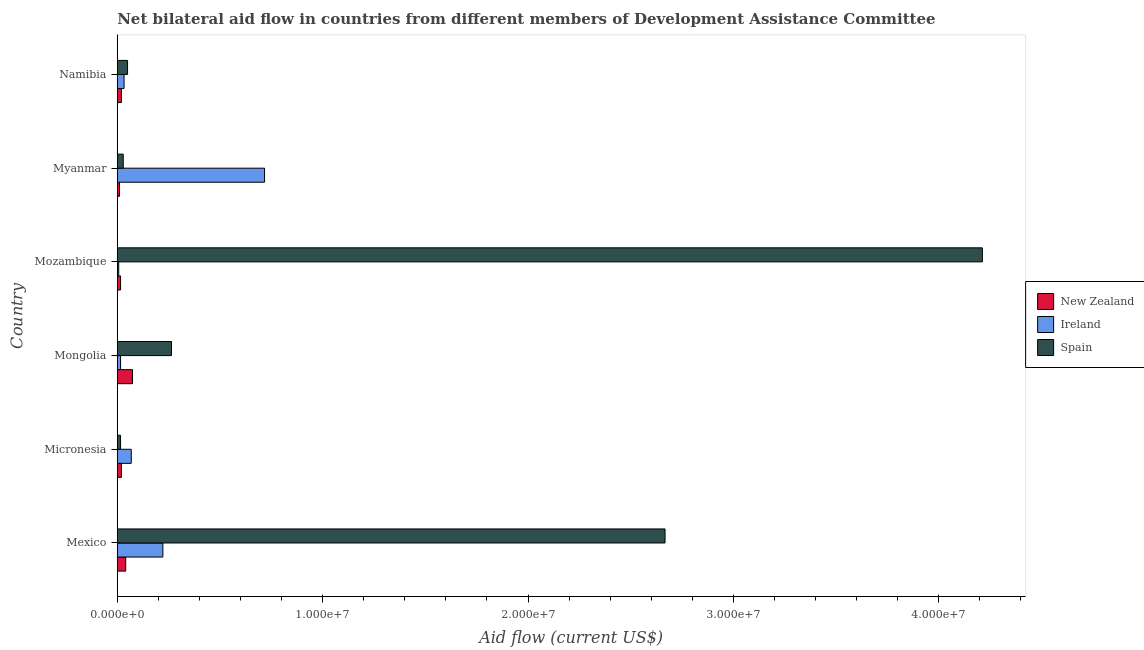Are the number of bars on each tick of the Y-axis equal?
Keep it short and to the point. Yes. How many bars are there on the 1st tick from the bottom?
Provide a succinct answer. 3. What is the label of the 1st group of bars from the top?
Ensure brevity in your answer.  Namibia. In how many cases, is the number of bars for a given country not equal to the number of legend labels?
Ensure brevity in your answer.  0. What is the amount of aid provided by new zealand in Namibia?
Ensure brevity in your answer.  2.00e+05. Across all countries, what is the maximum amount of aid provided by ireland?
Your response must be concise. 7.17e+06. Across all countries, what is the minimum amount of aid provided by new zealand?
Give a very brief answer. 1.10e+05. In which country was the amount of aid provided by ireland maximum?
Offer a very short reply. Myanmar. In which country was the amount of aid provided by new zealand minimum?
Offer a very short reply. Myanmar. What is the total amount of aid provided by new zealand in the graph?
Your answer should be very brief. 1.82e+06. What is the difference between the amount of aid provided by ireland in Mongolia and that in Namibia?
Your answer should be very brief. -1.70e+05. What is the difference between the amount of aid provided by spain in Mozambique and the amount of aid provided by ireland in Namibia?
Make the answer very short. 4.18e+07. What is the average amount of aid provided by new zealand per country?
Keep it short and to the point. 3.03e+05. What is the difference between the amount of aid provided by new zealand and amount of aid provided by ireland in Myanmar?
Your answer should be compact. -7.06e+06. In how many countries, is the amount of aid provided by spain greater than 34000000 US$?
Give a very brief answer. 1. What is the ratio of the amount of aid provided by ireland in Mongolia to that in Namibia?
Give a very brief answer. 0.48. Is the amount of aid provided by ireland in Mexico less than that in Myanmar?
Provide a succinct answer. Yes. Is the difference between the amount of aid provided by new zealand in Mongolia and Myanmar greater than the difference between the amount of aid provided by ireland in Mongolia and Myanmar?
Offer a terse response. Yes. What is the difference between the highest and the second highest amount of aid provided by new zealand?
Offer a very short reply. 3.30e+05. What is the difference between the highest and the lowest amount of aid provided by spain?
Ensure brevity in your answer.  4.20e+07. Is the sum of the amount of aid provided by new zealand in Micronesia and Mongolia greater than the maximum amount of aid provided by ireland across all countries?
Your response must be concise. No. What does the 3rd bar from the top in Micronesia represents?
Provide a short and direct response. New Zealand. What does the 1st bar from the bottom in Mexico represents?
Provide a succinct answer. New Zealand. Is it the case that in every country, the sum of the amount of aid provided by new zealand and amount of aid provided by ireland is greater than the amount of aid provided by spain?
Keep it short and to the point. No. How many countries are there in the graph?
Your answer should be compact. 6. What is the difference between two consecutive major ticks on the X-axis?
Provide a short and direct response. 1.00e+07. Are the values on the major ticks of X-axis written in scientific E-notation?
Keep it short and to the point. Yes. Where does the legend appear in the graph?
Make the answer very short. Center right. How many legend labels are there?
Your answer should be very brief. 3. What is the title of the graph?
Give a very brief answer. Net bilateral aid flow in countries from different members of Development Assistance Committee. What is the label or title of the X-axis?
Your answer should be very brief. Aid flow (current US$). What is the Aid flow (current US$) of Ireland in Mexico?
Provide a short and direct response. 2.22e+06. What is the Aid flow (current US$) in Spain in Mexico?
Offer a very short reply. 2.67e+07. What is the Aid flow (current US$) of New Zealand in Micronesia?
Ensure brevity in your answer.  2.00e+05. What is the Aid flow (current US$) in Ireland in Micronesia?
Keep it short and to the point. 6.80e+05. What is the Aid flow (current US$) in Spain in Micronesia?
Provide a succinct answer. 1.60e+05. What is the Aid flow (current US$) in New Zealand in Mongolia?
Your answer should be very brief. 7.40e+05. What is the Aid flow (current US$) of Spain in Mongolia?
Keep it short and to the point. 2.64e+06. What is the Aid flow (current US$) of Ireland in Mozambique?
Provide a short and direct response. 7.00e+04. What is the Aid flow (current US$) in Spain in Mozambique?
Your answer should be compact. 4.21e+07. What is the Aid flow (current US$) of New Zealand in Myanmar?
Give a very brief answer. 1.10e+05. What is the Aid flow (current US$) of Ireland in Myanmar?
Give a very brief answer. 7.17e+06. What is the Aid flow (current US$) of New Zealand in Namibia?
Give a very brief answer. 2.00e+05. What is the Aid flow (current US$) in Ireland in Namibia?
Offer a terse response. 3.30e+05. What is the Aid flow (current US$) in Spain in Namibia?
Provide a short and direct response. 5.00e+05. Across all countries, what is the maximum Aid flow (current US$) in New Zealand?
Make the answer very short. 7.40e+05. Across all countries, what is the maximum Aid flow (current US$) of Ireland?
Give a very brief answer. 7.17e+06. Across all countries, what is the maximum Aid flow (current US$) in Spain?
Your answer should be very brief. 4.21e+07. Across all countries, what is the minimum Aid flow (current US$) of Ireland?
Your response must be concise. 7.00e+04. Across all countries, what is the minimum Aid flow (current US$) of Spain?
Provide a short and direct response. 1.60e+05. What is the total Aid flow (current US$) of New Zealand in the graph?
Your response must be concise. 1.82e+06. What is the total Aid flow (current US$) of Ireland in the graph?
Make the answer very short. 1.06e+07. What is the total Aid flow (current US$) of Spain in the graph?
Provide a short and direct response. 7.24e+07. What is the difference between the Aid flow (current US$) of Ireland in Mexico and that in Micronesia?
Offer a very short reply. 1.54e+06. What is the difference between the Aid flow (current US$) in Spain in Mexico and that in Micronesia?
Make the answer very short. 2.65e+07. What is the difference between the Aid flow (current US$) in New Zealand in Mexico and that in Mongolia?
Give a very brief answer. -3.30e+05. What is the difference between the Aid flow (current US$) in Ireland in Mexico and that in Mongolia?
Offer a terse response. 2.06e+06. What is the difference between the Aid flow (current US$) in Spain in Mexico and that in Mongolia?
Give a very brief answer. 2.40e+07. What is the difference between the Aid flow (current US$) of Ireland in Mexico and that in Mozambique?
Offer a very short reply. 2.15e+06. What is the difference between the Aid flow (current US$) in Spain in Mexico and that in Mozambique?
Offer a terse response. -1.54e+07. What is the difference between the Aid flow (current US$) of New Zealand in Mexico and that in Myanmar?
Offer a very short reply. 3.00e+05. What is the difference between the Aid flow (current US$) of Ireland in Mexico and that in Myanmar?
Provide a succinct answer. -4.95e+06. What is the difference between the Aid flow (current US$) in Spain in Mexico and that in Myanmar?
Give a very brief answer. 2.64e+07. What is the difference between the Aid flow (current US$) of New Zealand in Mexico and that in Namibia?
Provide a succinct answer. 2.10e+05. What is the difference between the Aid flow (current US$) in Ireland in Mexico and that in Namibia?
Ensure brevity in your answer.  1.89e+06. What is the difference between the Aid flow (current US$) in Spain in Mexico and that in Namibia?
Offer a very short reply. 2.62e+07. What is the difference between the Aid flow (current US$) in New Zealand in Micronesia and that in Mongolia?
Offer a terse response. -5.40e+05. What is the difference between the Aid flow (current US$) of Ireland in Micronesia and that in Mongolia?
Your response must be concise. 5.20e+05. What is the difference between the Aid flow (current US$) of Spain in Micronesia and that in Mongolia?
Make the answer very short. -2.48e+06. What is the difference between the Aid flow (current US$) of Ireland in Micronesia and that in Mozambique?
Your answer should be very brief. 6.10e+05. What is the difference between the Aid flow (current US$) in Spain in Micronesia and that in Mozambique?
Provide a short and direct response. -4.20e+07. What is the difference between the Aid flow (current US$) of Ireland in Micronesia and that in Myanmar?
Your answer should be very brief. -6.49e+06. What is the difference between the Aid flow (current US$) in Spain in Micronesia and that in Myanmar?
Keep it short and to the point. -1.30e+05. What is the difference between the Aid flow (current US$) of New Zealand in Micronesia and that in Namibia?
Give a very brief answer. 0. What is the difference between the Aid flow (current US$) in New Zealand in Mongolia and that in Mozambique?
Keep it short and to the point. 5.80e+05. What is the difference between the Aid flow (current US$) in Ireland in Mongolia and that in Mozambique?
Offer a very short reply. 9.00e+04. What is the difference between the Aid flow (current US$) in Spain in Mongolia and that in Mozambique?
Offer a terse response. -3.95e+07. What is the difference between the Aid flow (current US$) in New Zealand in Mongolia and that in Myanmar?
Provide a succinct answer. 6.30e+05. What is the difference between the Aid flow (current US$) of Ireland in Mongolia and that in Myanmar?
Offer a very short reply. -7.01e+06. What is the difference between the Aid flow (current US$) in Spain in Mongolia and that in Myanmar?
Keep it short and to the point. 2.35e+06. What is the difference between the Aid flow (current US$) in New Zealand in Mongolia and that in Namibia?
Provide a short and direct response. 5.40e+05. What is the difference between the Aid flow (current US$) of Ireland in Mongolia and that in Namibia?
Provide a succinct answer. -1.70e+05. What is the difference between the Aid flow (current US$) of Spain in Mongolia and that in Namibia?
Make the answer very short. 2.14e+06. What is the difference between the Aid flow (current US$) in New Zealand in Mozambique and that in Myanmar?
Keep it short and to the point. 5.00e+04. What is the difference between the Aid flow (current US$) in Ireland in Mozambique and that in Myanmar?
Your response must be concise. -7.10e+06. What is the difference between the Aid flow (current US$) of Spain in Mozambique and that in Myanmar?
Keep it short and to the point. 4.18e+07. What is the difference between the Aid flow (current US$) of New Zealand in Mozambique and that in Namibia?
Keep it short and to the point. -4.00e+04. What is the difference between the Aid flow (current US$) of Ireland in Mozambique and that in Namibia?
Provide a short and direct response. -2.60e+05. What is the difference between the Aid flow (current US$) of Spain in Mozambique and that in Namibia?
Keep it short and to the point. 4.16e+07. What is the difference between the Aid flow (current US$) of Ireland in Myanmar and that in Namibia?
Offer a very short reply. 6.84e+06. What is the difference between the Aid flow (current US$) of New Zealand in Mexico and the Aid flow (current US$) of Spain in Micronesia?
Make the answer very short. 2.50e+05. What is the difference between the Aid flow (current US$) in Ireland in Mexico and the Aid flow (current US$) in Spain in Micronesia?
Offer a very short reply. 2.06e+06. What is the difference between the Aid flow (current US$) of New Zealand in Mexico and the Aid flow (current US$) of Spain in Mongolia?
Your answer should be very brief. -2.23e+06. What is the difference between the Aid flow (current US$) of Ireland in Mexico and the Aid flow (current US$) of Spain in Mongolia?
Make the answer very short. -4.20e+05. What is the difference between the Aid flow (current US$) in New Zealand in Mexico and the Aid flow (current US$) in Spain in Mozambique?
Your response must be concise. -4.17e+07. What is the difference between the Aid flow (current US$) of Ireland in Mexico and the Aid flow (current US$) of Spain in Mozambique?
Provide a short and direct response. -3.99e+07. What is the difference between the Aid flow (current US$) of New Zealand in Mexico and the Aid flow (current US$) of Ireland in Myanmar?
Make the answer very short. -6.76e+06. What is the difference between the Aid flow (current US$) of New Zealand in Mexico and the Aid flow (current US$) of Spain in Myanmar?
Keep it short and to the point. 1.20e+05. What is the difference between the Aid flow (current US$) of Ireland in Mexico and the Aid flow (current US$) of Spain in Myanmar?
Your answer should be very brief. 1.93e+06. What is the difference between the Aid flow (current US$) of Ireland in Mexico and the Aid flow (current US$) of Spain in Namibia?
Make the answer very short. 1.72e+06. What is the difference between the Aid flow (current US$) of New Zealand in Micronesia and the Aid flow (current US$) of Spain in Mongolia?
Give a very brief answer. -2.44e+06. What is the difference between the Aid flow (current US$) of Ireland in Micronesia and the Aid flow (current US$) of Spain in Mongolia?
Your answer should be very brief. -1.96e+06. What is the difference between the Aid flow (current US$) in New Zealand in Micronesia and the Aid flow (current US$) in Spain in Mozambique?
Give a very brief answer. -4.19e+07. What is the difference between the Aid flow (current US$) of Ireland in Micronesia and the Aid flow (current US$) of Spain in Mozambique?
Give a very brief answer. -4.14e+07. What is the difference between the Aid flow (current US$) of New Zealand in Micronesia and the Aid flow (current US$) of Ireland in Myanmar?
Provide a short and direct response. -6.97e+06. What is the difference between the Aid flow (current US$) in New Zealand in Micronesia and the Aid flow (current US$) in Spain in Myanmar?
Offer a very short reply. -9.00e+04. What is the difference between the Aid flow (current US$) in New Zealand in Micronesia and the Aid flow (current US$) in Ireland in Namibia?
Offer a very short reply. -1.30e+05. What is the difference between the Aid flow (current US$) of New Zealand in Micronesia and the Aid flow (current US$) of Spain in Namibia?
Provide a short and direct response. -3.00e+05. What is the difference between the Aid flow (current US$) of New Zealand in Mongolia and the Aid flow (current US$) of Ireland in Mozambique?
Your answer should be very brief. 6.70e+05. What is the difference between the Aid flow (current US$) of New Zealand in Mongolia and the Aid flow (current US$) of Spain in Mozambique?
Keep it short and to the point. -4.14e+07. What is the difference between the Aid flow (current US$) in Ireland in Mongolia and the Aid flow (current US$) in Spain in Mozambique?
Keep it short and to the point. -4.20e+07. What is the difference between the Aid flow (current US$) of New Zealand in Mongolia and the Aid flow (current US$) of Ireland in Myanmar?
Provide a short and direct response. -6.43e+06. What is the difference between the Aid flow (current US$) in New Zealand in Mongolia and the Aid flow (current US$) in Spain in Myanmar?
Your response must be concise. 4.50e+05. What is the difference between the Aid flow (current US$) in Ireland in Mongolia and the Aid flow (current US$) in Spain in Myanmar?
Offer a terse response. -1.30e+05. What is the difference between the Aid flow (current US$) of New Zealand in Mongolia and the Aid flow (current US$) of Spain in Namibia?
Your response must be concise. 2.40e+05. What is the difference between the Aid flow (current US$) in Ireland in Mongolia and the Aid flow (current US$) in Spain in Namibia?
Provide a succinct answer. -3.40e+05. What is the difference between the Aid flow (current US$) in New Zealand in Mozambique and the Aid flow (current US$) in Ireland in Myanmar?
Provide a succinct answer. -7.01e+06. What is the difference between the Aid flow (current US$) of New Zealand in Mozambique and the Aid flow (current US$) of Ireland in Namibia?
Provide a short and direct response. -1.70e+05. What is the difference between the Aid flow (current US$) in New Zealand in Mozambique and the Aid flow (current US$) in Spain in Namibia?
Give a very brief answer. -3.40e+05. What is the difference between the Aid flow (current US$) of Ireland in Mozambique and the Aid flow (current US$) of Spain in Namibia?
Your answer should be compact. -4.30e+05. What is the difference between the Aid flow (current US$) in New Zealand in Myanmar and the Aid flow (current US$) in Ireland in Namibia?
Offer a very short reply. -2.20e+05. What is the difference between the Aid flow (current US$) in New Zealand in Myanmar and the Aid flow (current US$) in Spain in Namibia?
Your answer should be compact. -3.90e+05. What is the difference between the Aid flow (current US$) in Ireland in Myanmar and the Aid flow (current US$) in Spain in Namibia?
Make the answer very short. 6.67e+06. What is the average Aid flow (current US$) of New Zealand per country?
Offer a terse response. 3.03e+05. What is the average Aid flow (current US$) in Ireland per country?
Offer a very short reply. 1.77e+06. What is the average Aid flow (current US$) in Spain per country?
Make the answer very short. 1.21e+07. What is the difference between the Aid flow (current US$) of New Zealand and Aid flow (current US$) of Ireland in Mexico?
Offer a terse response. -1.81e+06. What is the difference between the Aid flow (current US$) in New Zealand and Aid flow (current US$) in Spain in Mexico?
Provide a succinct answer. -2.63e+07. What is the difference between the Aid flow (current US$) of Ireland and Aid flow (current US$) of Spain in Mexico?
Provide a succinct answer. -2.44e+07. What is the difference between the Aid flow (current US$) in New Zealand and Aid flow (current US$) in Ireland in Micronesia?
Make the answer very short. -4.80e+05. What is the difference between the Aid flow (current US$) of Ireland and Aid flow (current US$) of Spain in Micronesia?
Provide a succinct answer. 5.20e+05. What is the difference between the Aid flow (current US$) of New Zealand and Aid flow (current US$) of Ireland in Mongolia?
Your answer should be very brief. 5.80e+05. What is the difference between the Aid flow (current US$) in New Zealand and Aid flow (current US$) in Spain in Mongolia?
Offer a terse response. -1.90e+06. What is the difference between the Aid flow (current US$) in Ireland and Aid flow (current US$) in Spain in Mongolia?
Make the answer very short. -2.48e+06. What is the difference between the Aid flow (current US$) of New Zealand and Aid flow (current US$) of Spain in Mozambique?
Provide a short and direct response. -4.20e+07. What is the difference between the Aid flow (current US$) of Ireland and Aid flow (current US$) of Spain in Mozambique?
Provide a short and direct response. -4.20e+07. What is the difference between the Aid flow (current US$) of New Zealand and Aid flow (current US$) of Ireland in Myanmar?
Your answer should be very brief. -7.06e+06. What is the difference between the Aid flow (current US$) in New Zealand and Aid flow (current US$) in Spain in Myanmar?
Make the answer very short. -1.80e+05. What is the difference between the Aid flow (current US$) of Ireland and Aid flow (current US$) of Spain in Myanmar?
Provide a short and direct response. 6.88e+06. What is the difference between the Aid flow (current US$) of New Zealand and Aid flow (current US$) of Spain in Namibia?
Ensure brevity in your answer.  -3.00e+05. What is the difference between the Aid flow (current US$) in Ireland and Aid flow (current US$) in Spain in Namibia?
Your response must be concise. -1.70e+05. What is the ratio of the Aid flow (current US$) in New Zealand in Mexico to that in Micronesia?
Make the answer very short. 2.05. What is the ratio of the Aid flow (current US$) in Ireland in Mexico to that in Micronesia?
Provide a short and direct response. 3.26. What is the ratio of the Aid flow (current US$) of Spain in Mexico to that in Micronesia?
Make the answer very short. 166.69. What is the ratio of the Aid flow (current US$) of New Zealand in Mexico to that in Mongolia?
Provide a short and direct response. 0.55. What is the ratio of the Aid flow (current US$) in Ireland in Mexico to that in Mongolia?
Give a very brief answer. 13.88. What is the ratio of the Aid flow (current US$) of Spain in Mexico to that in Mongolia?
Provide a short and direct response. 10.1. What is the ratio of the Aid flow (current US$) in New Zealand in Mexico to that in Mozambique?
Provide a succinct answer. 2.56. What is the ratio of the Aid flow (current US$) in Ireland in Mexico to that in Mozambique?
Provide a short and direct response. 31.71. What is the ratio of the Aid flow (current US$) of Spain in Mexico to that in Mozambique?
Ensure brevity in your answer.  0.63. What is the ratio of the Aid flow (current US$) in New Zealand in Mexico to that in Myanmar?
Your response must be concise. 3.73. What is the ratio of the Aid flow (current US$) of Ireland in Mexico to that in Myanmar?
Your response must be concise. 0.31. What is the ratio of the Aid flow (current US$) in Spain in Mexico to that in Myanmar?
Offer a terse response. 91.97. What is the ratio of the Aid flow (current US$) in New Zealand in Mexico to that in Namibia?
Provide a short and direct response. 2.05. What is the ratio of the Aid flow (current US$) in Ireland in Mexico to that in Namibia?
Your answer should be very brief. 6.73. What is the ratio of the Aid flow (current US$) in Spain in Mexico to that in Namibia?
Offer a very short reply. 53.34. What is the ratio of the Aid flow (current US$) in New Zealand in Micronesia to that in Mongolia?
Keep it short and to the point. 0.27. What is the ratio of the Aid flow (current US$) of Ireland in Micronesia to that in Mongolia?
Give a very brief answer. 4.25. What is the ratio of the Aid flow (current US$) in Spain in Micronesia to that in Mongolia?
Provide a short and direct response. 0.06. What is the ratio of the Aid flow (current US$) of Ireland in Micronesia to that in Mozambique?
Keep it short and to the point. 9.71. What is the ratio of the Aid flow (current US$) in Spain in Micronesia to that in Mozambique?
Provide a succinct answer. 0. What is the ratio of the Aid flow (current US$) of New Zealand in Micronesia to that in Myanmar?
Your answer should be compact. 1.82. What is the ratio of the Aid flow (current US$) in Ireland in Micronesia to that in Myanmar?
Provide a short and direct response. 0.09. What is the ratio of the Aid flow (current US$) of Spain in Micronesia to that in Myanmar?
Offer a very short reply. 0.55. What is the ratio of the Aid flow (current US$) of Ireland in Micronesia to that in Namibia?
Your answer should be compact. 2.06. What is the ratio of the Aid flow (current US$) in Spain in Micronesia to that in Namibia?
Provide a short and direct response. 0.32. What is the ratio of the Aid flow (current US$) in New Zealand in Mongolia to that in Mozambique?
Offer a very short reply. 4.62. What is the ratio of the Aid flow (current US$) of Ireland in Mongolia to that in Mozambique?
Keep it short and to the point. 2.29. What is the ratio of the Aid flow (current US$) in Spain in Mongolia to that in Mozambique?
Keep it short and to the point. 0.06. What is the ratio of the Aid flow (current US$) of New Zealand in Mongolia to that in Myanmar?
Your answer should be very brief. 6.73. What is the ratio of the Aid flow (current US$) in Ireland in Mongolia to that in Myanmar?
Your answer should be very brief. 0.02. What is the ratio of the Aid flow (current US$) of Spain in Mongolia to that in Myanmar?
Your answer should be very brief. 9.1. What is the ratio of the Aid flow (current US$) of Ireland in Mongolia to that in Namibia?
Ensure brevity in your answer.  0.48. What is the ratio of the Aid flow (current US$) of Spain in Mongolia to that in Namibia?
Provide a succinct answer. 5.28. What is the ratio of the Aid flow (current US$) of New Zealand in Mozambique to that in Myanmar?
Provide a short and direct response. 1.45. What is the ratio of the Aid flow (current US$) in Ireland in Mozambique to that in Myanmar?
Offer a very short reply. 0.01. What is the ratio of the Aid flow (current US$) of Spain in Mozambique to that in Myanmar?
Your answer should be compact. 145.24. What is the ratio of the Aid flow (current US$) in New Zealand in Mozambique to that in Namibia?
Provide a short and direct response. 0.8. What is the ratio of the Aid flow (current US$) in Ireland in Mozambique to that in Namibia?
Offer a very short reply. 0.21. What is the ratio of the Aid flow (current US$) of Spain in Mozambique to that in Namibia?
Your answer should be compact. 84.24. What is the ratio of the Aid flow (current US$) of New Zealand in Myanmar to that in Namibia?
Give a very brief answer. 0.55. What is the ratio of the Aid flow (current US$) of Ireland in Myanmar to that in Namibia?
Give a very brief answer. 21.73. What is the ratio of the Aid flow (current US$) of Spain in Myanmar to that in Namibia?
Give a very brief answer. 0.58. What is the difference between the highest and the second highest Aid flow (current US$) of New Zealand?
Make the answer very short. 3.30e+05. What is the difference between the highest and the second highest Aid flow (current US$) of Ireland?
Keep it short and to the point. 4.95e+06. What is the difference between the highest and the second highest Aid flow (current US$) of Spain?
Keep it short and to the point. 1.54e+07. What is the difference between the highest and the lowest Aid flow (current US$) of New Zealand?
Ensure brevity in your answer.  6.30e+05. What is the difference between the highest and the lowest Aid flow (current US$) of Ireland?
Provide a succinct answer. 7.10e+06. What is the difference between the highest and the lowest Aid flow (current US$) in Spain?
Keep it short and to the point. 4.20e+07. 